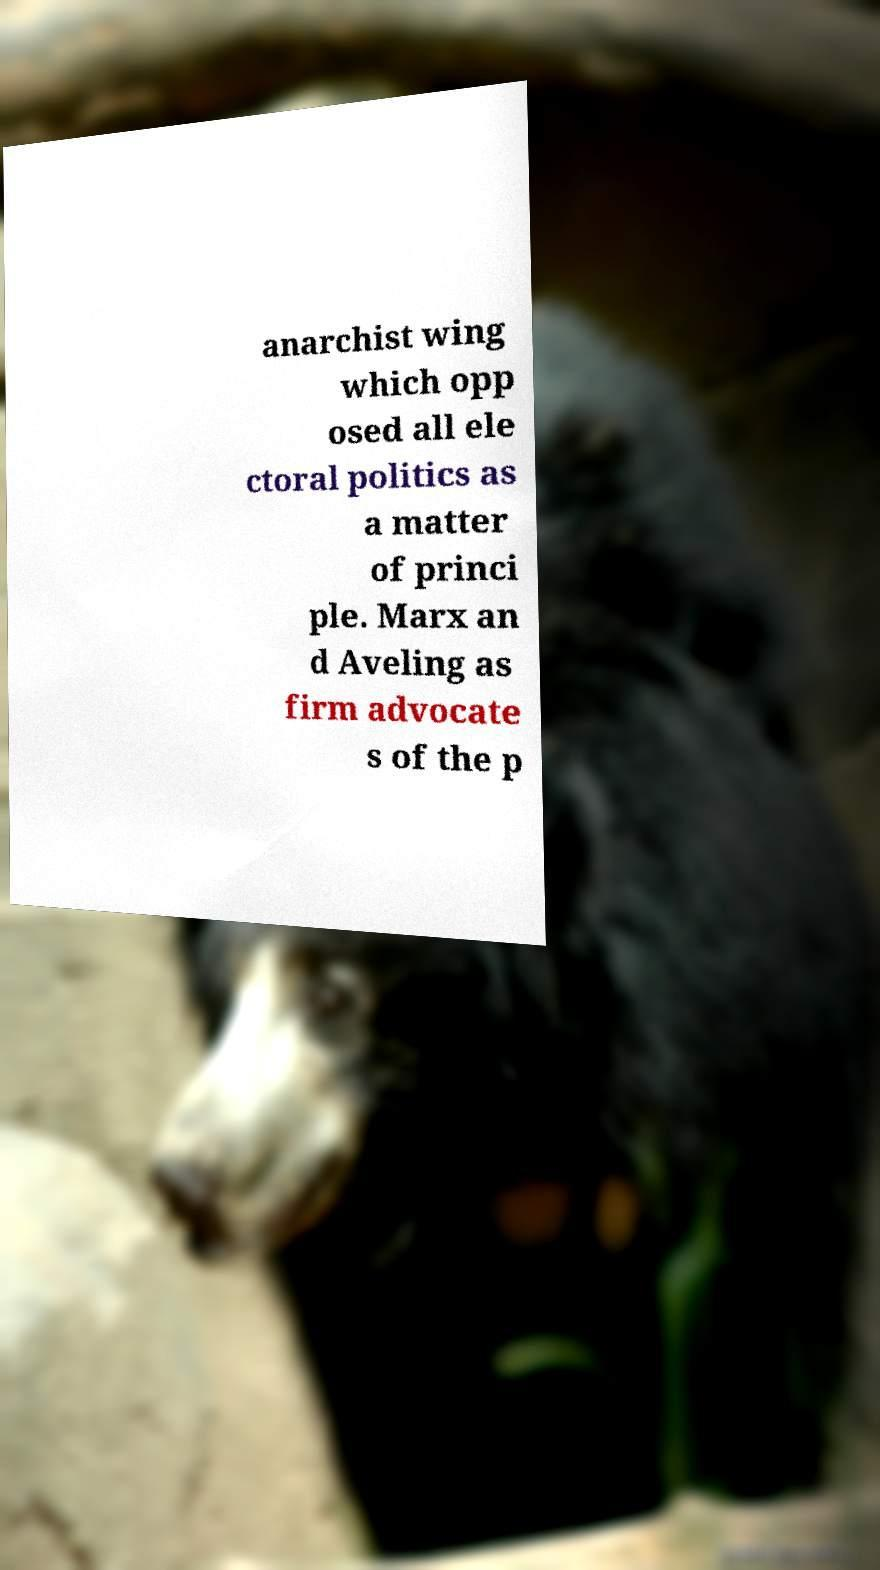There's text embedded in this image that I need extracted. Can you transcribe it verbatim? anarchist wing which opp osed all ele ctoral politics as a matter of princi ple. Marx an d Aveling as firm advocate s of the p 